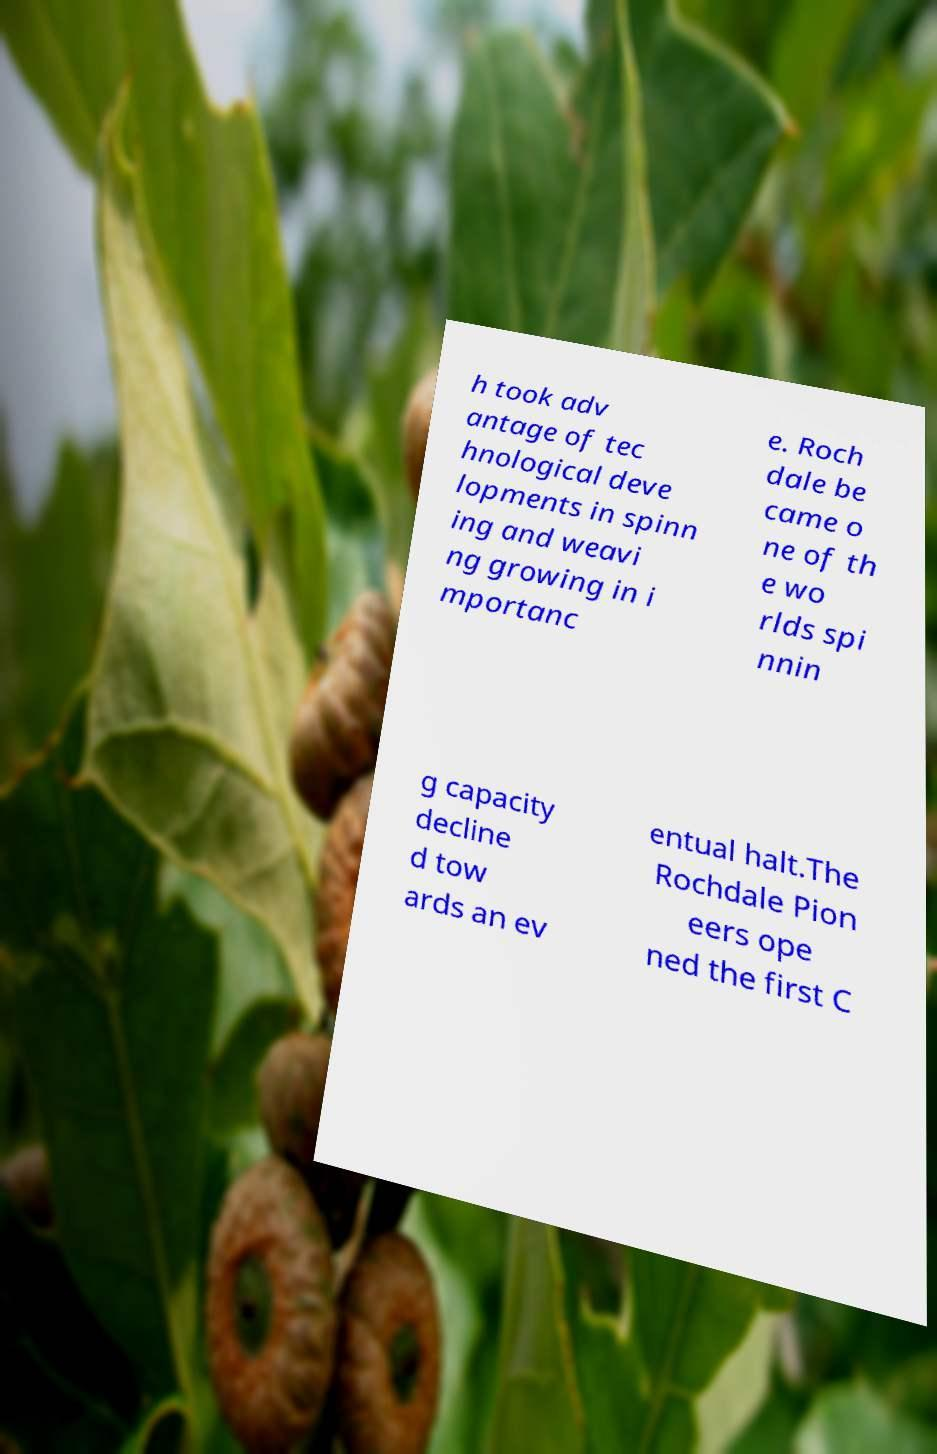I need the written content from this picture converted into text. Can you do that? h took adv antage of tec hnological deve lopments in spinn ing and weavi ng growing in i mportanc e. Roch dale be came o ne of th e wo rlds spi nnin g capacity decline d tow ards an ev entual halt.The Rochdale Pion eers ope ned the first C 